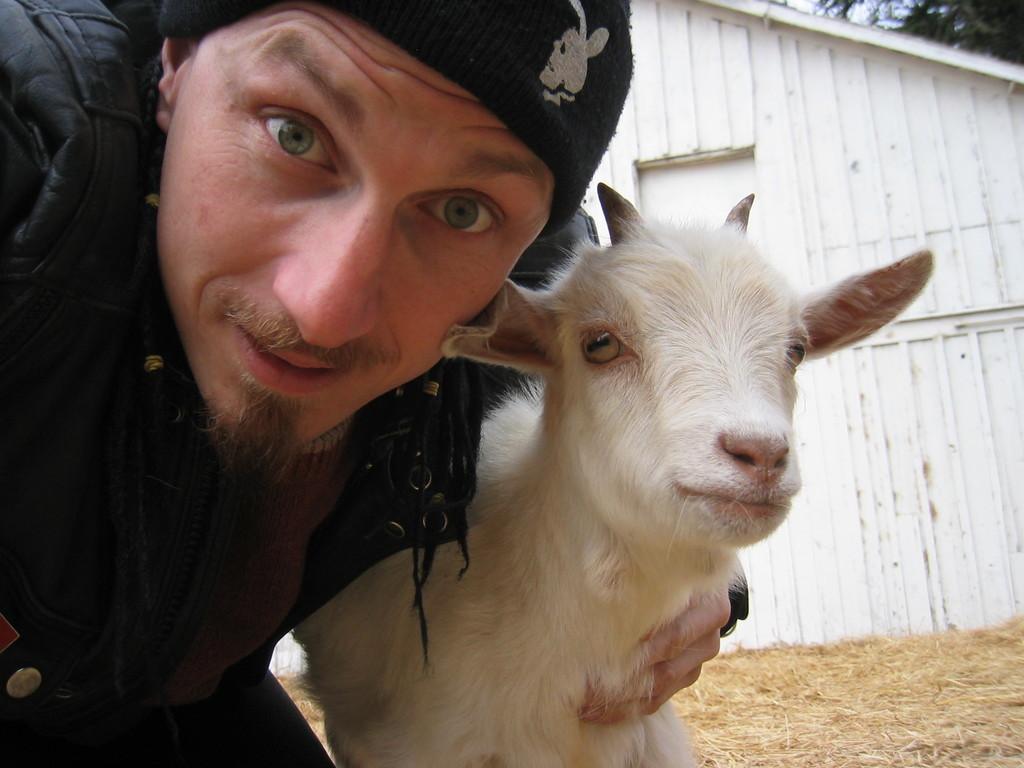In one or two sentences, can you explain what this image depicts? On the left side of this image there is a man holding a goat in the hand and looking at the picture. This goat is in white color. In the background, I can see the dry grass on the ground and there is a shed. 